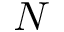Convert formula to latex. <formula><loc_0><loc_0><loc_500><loc_500>N</formula> 